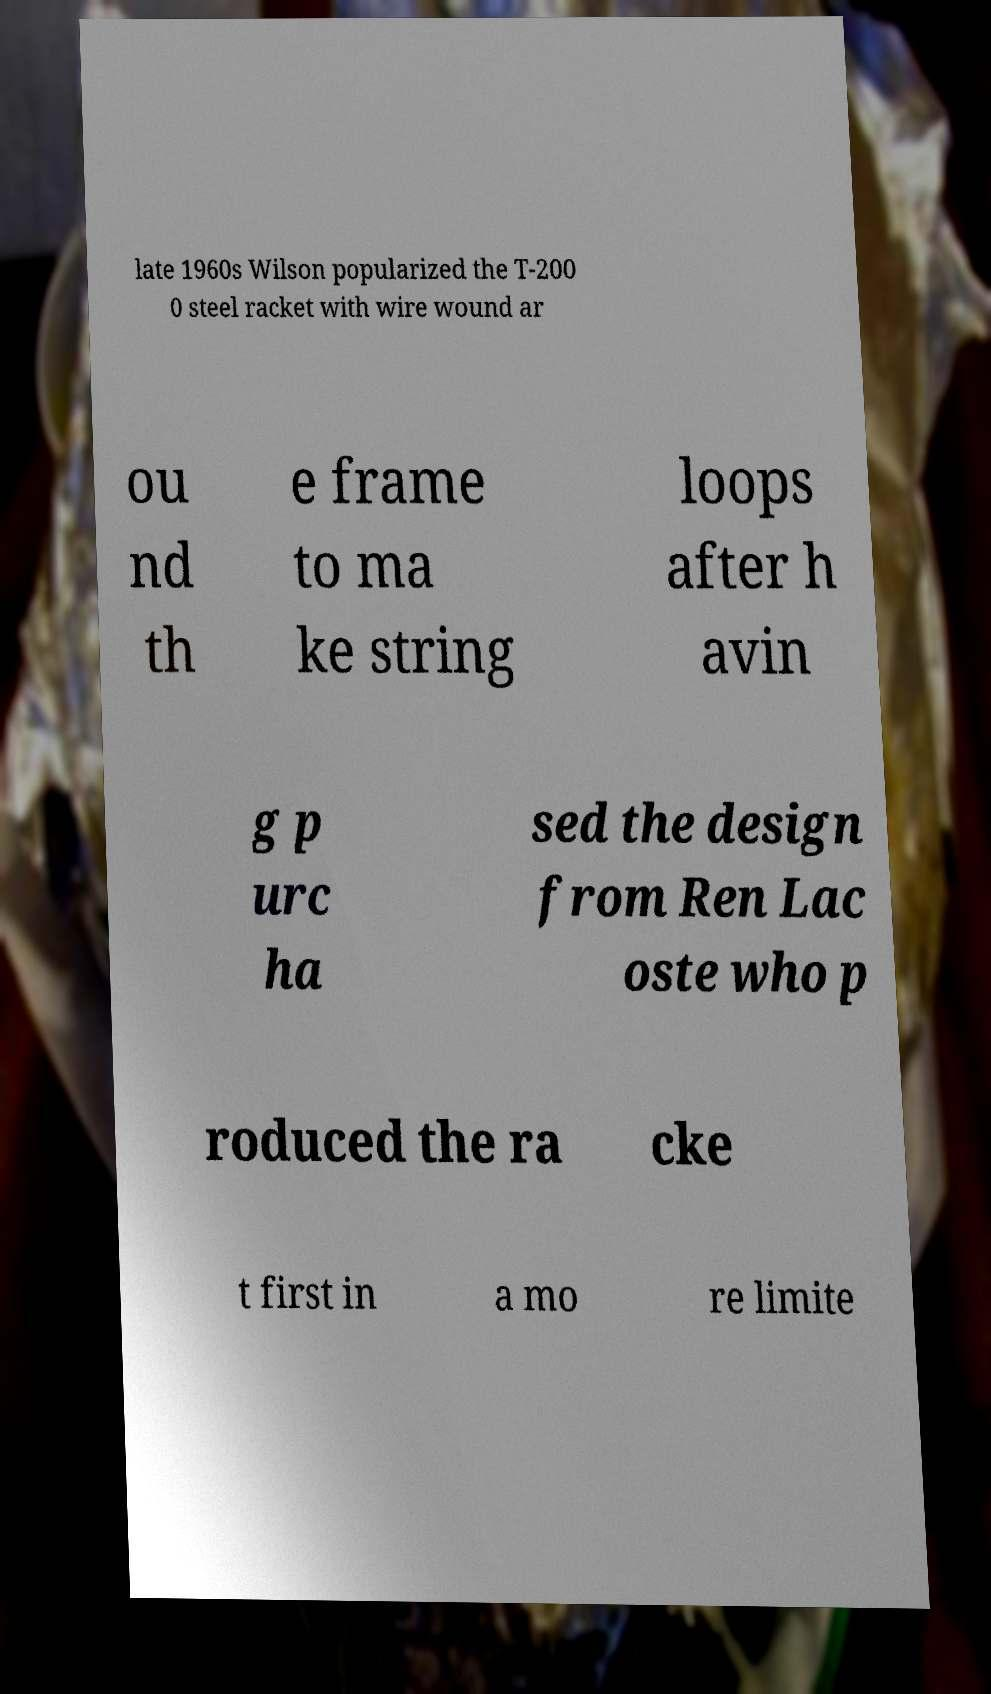Please read and relay the text visible in this image. What does it say? late 1960s Wilson popularized the T-200 0 steel racket with wire wound ar ou nd th e frame to ma ke string loops after h avin g p urc ha sed the design from Ren Lac oste who p roduced the ra cke t first in a mo re limite 